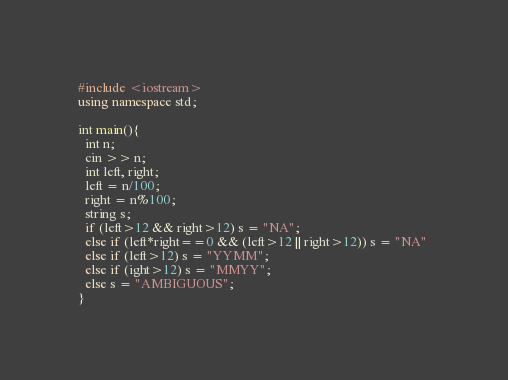Convert code to text. <code><loc_0><loc_0><loc_500><loc_500><_C++_>#include <iostream>
using namespace std;

int main(){
  int n;
  cin >> n;
  int left, right;
  left = n/100;
  right = n%100;
  string s;
  if (left>12 && right>12) s = "NA";
  else if (left*right==0 && (left>12 || right>12)) s = "NA" 
  else if (left>12) s = "YYMM";
  else if (ight>12) s = "MMYY";
  else s = "AMBIGUOUS";
}</code> 